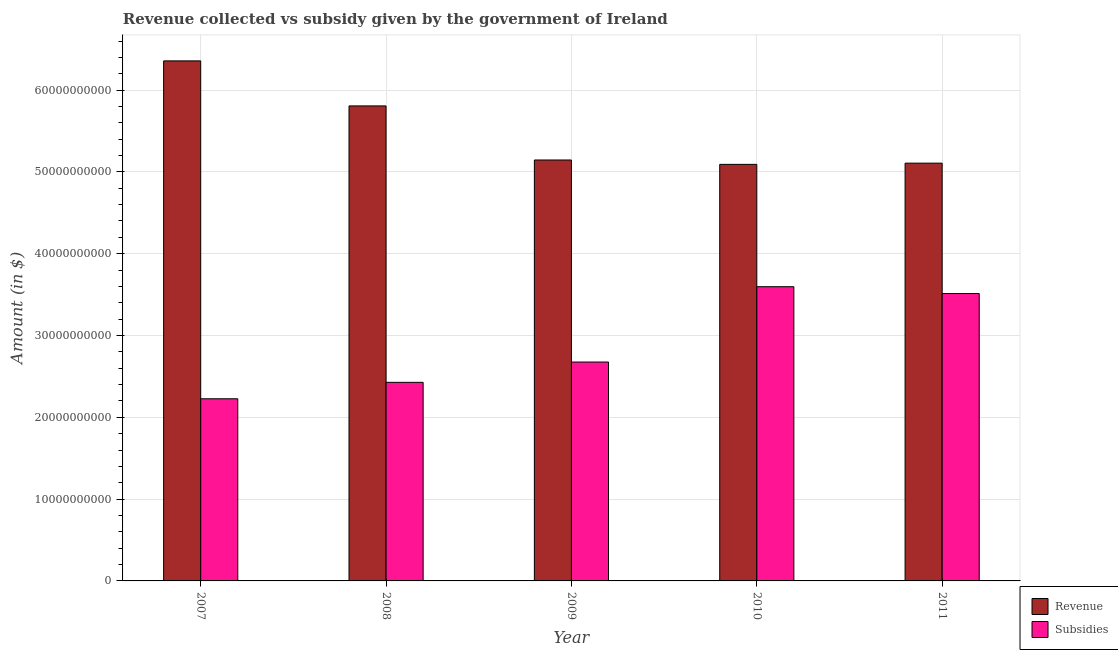How many groups of bars are there?
Your answer should be compact. 5. How many bars are there on the 1st tick from the left?
Provide a succinct answer. 2. How many bars are there on the 5th tick from the right?
Your answer should be compact. 2. What is the label of the 1st group of bars from the left?
Your answer should be compact. 2007. What is the amount of subsidies given in 2011?
Give a very brief answer. 3.51e+1. Across all years, what is the maximum amount of revenue collected?
Make the answer very short. 6.36e+1. Across all years, what is the minimum amount of subsidies given?
Make the answer very short. 2.23e+1. What is the total amount of subsidies given in the graph?
Offer a very short reply. 1.44e+11. What is the difference between the amount of subsidies given in 2010 and that in 2011?
Give a very brief answer. 8.34e+08. What is the difference between the amount of subsidies given in 2010 and the amount of revenue collected in 2007?
Ensure brevity in your answer.  1.37e+1. What is the average amount of revenue collected per year?
Offer a very short reply. 5.50e+1. In the year 2008, what is the difference between the amount of subsidies given and amount of revenue collected?
Provide a succinct answer. 0. What is the ratio of the amount of subsidies given in 2009 to that in 2011?
Your answer should be compact. 0.76. Is the amount of subsidies given in 2010 less than that in 2011?
Offer a very short reply. No. Is the difference between the amount of revenue collected in 2007 and 2009 greater than the difference between the amount of subsidies given in 2007 and 2009?
Offer a very short reply. No. What is the difference between the highest and the second highest amount of revenue collected?
Provide a succinct answer. 5.51e+09. What is the difference between the highest and the lowest amount of subsidies given?
Your answer should be very brief. 1.37e+1. Is the sum of the amount of revenue collected in 2008 and 2011 greater than the maximum amount of subsidies given across all years?
Make the answer very short. Yes. What does the 2nd bar from the left in 2007 represents?
Provide a short and direct response. Subsidies. What does the 1st bar from the right in 2011 represents?
Ensure brevity in your answer.  Subsidies. Are all the bars in the graph horizontal?
Make the answer very short. No. What is the difference between two consecutive major ticks on the Y-axis?
Provide a succinct answer. 1.00e+1. What is the title of the graph?
Offer a very short reply. Revenue collected vs subsidy given by the government of Ireland. Does "Non-solid fuel" appear as one of the legend labels in the graph?
Provide a succinct answer. No. What is the label or title of the Y-axis?
Keep it short and to the point. Amount (in $). What is the Amount (in $) of Revenue in 2007?
Your answer should be compact. 6.36e+1. What is the Amount (in $) in Subsidies in 2007?
Offer a very short reply. 2.23e+1. What is the Amount (in $) of Revenue in 2008?
Give a very brief answer. 5.81e+1. What is the Amount (in $) in Subsidies in 2008?
Make the answer very short. 2.43e+1. What is the Amount (in $) of Revenue in 2009?
Give a very brief answer. 5.15e+1. What is the Amount (in $) of Subsidies in 2009?
Offer a terse response. 2.68e+1. What is the Amount (in $) in Revenue in 2010?
Provide a succinct answer. 5.09e+1. What is the Amount (in $) in Subsidies in 2010?
Your answer should be compact. 3.60e+1. What is the Amount (in $) in Revenue in 2011?
Your answer should be compact. 5.11e+1. What is the Amount (in $) in Subsidies in 2011?
Keep it short and to the point. 3.51e+1. Across all years, what is the maximum Amount (in $) in Revenue?
Provide a short and direct response. 6.36e+1. Across all years, what is the maximum Amount (in $) in Subsidies?
Ensure brevity in your answer.  3.60e+1. Across all years, what is the minimum Amount (in $) in Revenue?
Give a very brief answer. 5.09e+1. Across all years, what is the minimum Amount (in $) in Subsidies?
Your response must be concise. 2.23e+1. What is the total Amount (in $) of Revenue in the graph?
Offer a terse response. 2.75e+11. What is the total Amount (in $) in Subsidies in the graph?
Your answer should be compact. 1.44e+11. What is the difference between the Amount (in $) of Revenue in 2007 and that in 2008?
Provide a short and direct response. 5.51e+09. What is the difference between the Amount (in $) in Subsidies in 2007 and that in 2008?
Your answer should be very brief. -2.01e+09. What is the difference between the Amount (in $) of Revenue in 2007 and that in 2009?
Keep it short and to the point. 1.21e+1. What is the difference between the Amount (in $) in Subsidies in 2007 and that in 2009?
Offer a terse response. -4.49e+09. What is the difference between the Amount (in $) in Revenue in 2007 and that in 2010?
Offer a terse response. 1.27e+1. What is the difference between the Amount (in $) of Subsidies in 2007 and that in 2010?
Ensure brevity in your answer.  -1.37e+1. What is the difference between the Amount (in $) of Revenue in 2007 and that in 2011?
Provide a succinct answer. 1.25e+1. What is the difference between the Amount (in $) in Subsidies in 2007 and that in 2011?
Your answer should be very brief. -1.29e+1. What is the difference between the Amount (in $) in Revenue in 2008 and that in 2009?
Provide a short and direct response. 6.61e+09. What is the difference between the Amount (in $) in Subsidies in 2008 and that in 2009?
Offer a very short reply. -2.48e+09. What is the difference between the Amount (in $) in Revenue in 2008 and that in 2010?
Offer a very short reply. 7.15e+09. What is the difference between the Amount (in $) in Subsidies in 2008 and that in 2010?
Keep it short and to the point. -1.17e+1. What is the difference between the Amount (in $) in Revenue in 2008 and that in 2011?
Provide a succinct answer. 7.00e+09. What is the difference between the Amount (in $) of Subsidies in 2008 and that in 2011?
Give a very brief answer. -1.09e+1. What is the difference between the Amount (in $) in Revenue in 2009 and that in 2010?
Make the answer very short. 5.34e+08. What is the difference between the Amount (in $) in Subsidies in 2009 and that in 2010?
Make the answer very short. -9.21e+09. What is the difference between the Amount (in $) of Revenue in 2009 and that in 2011?
Keep it short and to the point. 3.85e+08. What is the difference between the Amount (in $) in Subsidies in 2009 and that in 2011?
Your response must be concise. -8.38e+09. What is the difference between the Amount (in $) of Revenue in 2010 and that in 2011?
Ensure brevity in your answer.  -1.49e+08. What is the difference between the Amount (in $) in Subsidies in 2010 and that in 2011?
Your response must be concise. 8.34e+08. What is the difference between the Amount (in $) of Revenue in 2007 and the Amount (in $) of Subsidies in 2008?
Ensure brevity in your answer.  3.93e+1. What is the difference between the Amount (in $) of Revenue in 2007 and the Amount (in $) of Subsidies in 2009?
Provide a short and direct response. 3.68e+1. What is the difference between the Amount (in $) of Revenue in 2007 and the Amount (in $) of Subsidies in 2010?
Keep it short and to the point. 2.76e+1. What is the difference between the Amount (in $) in Revenue in 2007 and the Amount (in $) in Subsidies in 2011?
Your answer should be compact. 2.84e+1. What is the difference between the Amount (in $) of Revenue in 2008 and the Amount (in $) of Subsidies in 2009?
Provide a short and direct response. 3.13e+1. What is the difference between the Amount (in $) of Revenue in 2008 and the Amount (in $) of Subsidies in 2010?
Make the answer very short. 2.21e+1. What is the difference between the Amount (in $) of Revenue in 2008 and the Amount (in $) of Subsidies in 2011?
Provide a succinct answer. 2.29e+1. What is the difference between the Amount (in $) in Revenue in 2009 and the Amount (in $) in Subsidies in 2010?
Make the answer very short. 1.55e+1. What is the difference between the Amount (in $) in Revenue in 2009 and the Amount (in $) in Subsidies in 2011?
Provide a succinct answer. 1.63e+1. What is the difference between the Amount (in $) in Revenue in 2010 and the Amount (in $) in Subsidies in 2011?
Make the answer very short. 1.58e+1. What is the average Amount (in $) of Revenue per year?
Offer a terse response. 5.50e+1. What is the average Amount (in $) in Subsidies per year?
Provide a succinct answer. 2.89e+1. In the year 2007, what is the difference between the Amount (in $) in Revenue and Amount (in $) in Subsidies?
Provide a short and direct response. 4.13e+1. In the year 2008, what is the difference between the Amount (in $) in Revenue and Amount (in $) in Subsidies?
Your answer should be compact. 3.38e+1. In the year 2009, what is the difference between the Amount (in $) of Revenue and Amount (in $) of Subsidies?
Make the answer very short. 2.47e+1. In the year 2010, what is the difference between the Amount (in $) in Revenue and Amount (in $) in Subsidies?
Your answer should be very brief. 1.50e+1. In the year 2011, what is the difference between the Amount (in $) in Revenue and Amount (in $) in Subsidies?
Your response must be concise. 1.59e+1. What is the ratio of the Amount (in $) of Revenue in 2007 to that in 2008?
Make the answer very short. 1.09. What is the ratio of the Amount (in $) in Subsidies in 2007 to that in 2008?
Your response must be concise. 0.92. What is the ratio of the Amount (in $) in Revenue in 2007 to that in 2009?
Offer a terse response. 1.24. What is the ratio of the Amount (in $) of Subsidies in 2007 to that in 2009?
Give a very brief answer. 0.83. What is the ratio of the Amount (in $) of Revenue in 2007 to that in 2010?
Keep it short and to the point. 1.25. What is the ratio of the Amount (in $) of Subsidies in 2007 to that in 2010?
Your answer should be compact. 0.62. What is the ratio of the Amount (in $) in Revenue in 2007 to that in 2011?
Give a very brief answer. 1.24. What is the ratio of the Amount (in $) in Subsidies in 2007 to that in 2011?
Offer a very short reply. 0.63. What is the ratio of the Amount (in $) of Revenue in 2008 to that in 2009?
Your answer should be very brief. 1.13. What is the ratio of the Amount (in $) of Subsidies in 2008 to that in 2009?
Provide a succinct answer. 0.91. What is the ratio of the Amount (in $) in Revenue in 2008 to that in 2010?
Make the answer very short. 1.14. What is the ratio of the Amount (in $) in Subsidies in 2008 to that in 2010?
Offer a very short reply. 0.68. What is the ratio of the Amount (in $) of Revenue in 2008 to that in 2011?
Offer a very short reply. 1.14. What is the ratio of the Amount (in $) in Subsidies in 2008 to that in 2011?
Your response must be concise. 0.69. What is the ratio of the Amount (in $) of Revenue in 2009 to that in 2010?
Provide a succinct answer. 1.01. What is the ratio of the Amount (in $) of Subsidies in 2009 to that in 2010?
Give a very brief answer. 0.74. What is the ratio of the Amount (in $) of Revenue in 2009 to that in 2011?
Give a very brief answer. 1.01. What is the ratio of the Amount (in $) in Subsidies in 2009 to that in 2011?
Your response must be concise. 0.76. What is the ratio of the Amount (in $) in Subsidies in 2010 to that in 2011?
Your response must be concise. 1.02. What is the difference between the highest and the second highest Amount (in $) in Revenue?
Offer a terse response. 5.51e+09. What is the difference between the highest and the second highest Amount (in $) in Subsidies?
Give a very brief answer. 8.34e+08. What is the difference between the highest and the lowest Amount (in $) in Revenue?
Keep it short and to the point. 1.27e+1. What is the difference between the highest and the lowest Amount (in $) in Subsidies?
Offer a very short reply. 1.37e+1. 